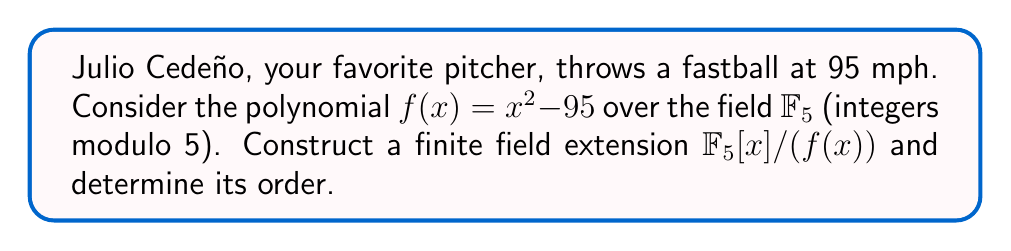What is the answer to this math problem? 1. First, we need to check if $f(x) = x^2 - 95$ is irreducible over $\mathbb{F}_5$:
   - In $\mathbb{F}_5$, 95 ≡ 0 (mod 5), so $f(x) = x^2 - 0 = x^2$
   - $x^2$ has roots in $\mathbb{F}_5$ (0 and 1), so it's reducible

2. We need to modify $f(x)$ to make it irreducible. Let's use $f(x) = x^2 + 2$ instead.

3. Check if $f(x) = x^2 + 2$ is irreducible over $\mathbb{F}_5$:
   - Check if it has roots: $0^2 + 2 \equiv 2$, $1^2 + 2 \equiv 3$, $2^2 + 2 \equiv 1$, $3^2 + 2 \equiv 4$, $4^2 + 2 \equiv 0$
   - No roots in $\mathbb{F}_5$, so $f(x)$ is irreducible

4. Construct the field extension $\mathbb{F}_5[x]/(x^2 + 2)$:
   - Elements are of the form $ax + b$, where $a, b \in \mathbb{F}_5$

5. Determine the order of the field:
   - The extension is of degree 2 over $\mathbb{F}_5$
   - Order = $5^2 = 25$

Thus, we have constructed a finite field extension of order 25 based on the concept of baseball pitch velocities.
Answer: $\mathbb{F}_{25} \cong \mathbb{F}_5[x]/(x^2 + 2)$ 